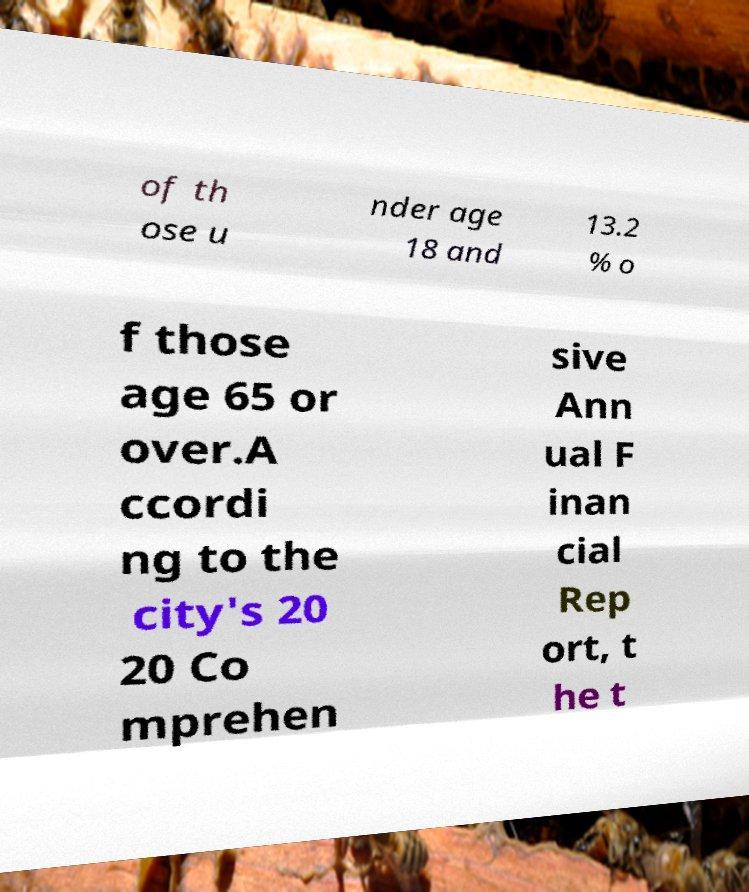For documentation purposes, I need the text within this image transcribed. Could you provide that? of th ose u nder age 18 and 13.2 % o f those age 65 or over.A ccordi ng to the city's 20 20 Co mprehen sive Ann ual F inan cial Rep ort, t he t 